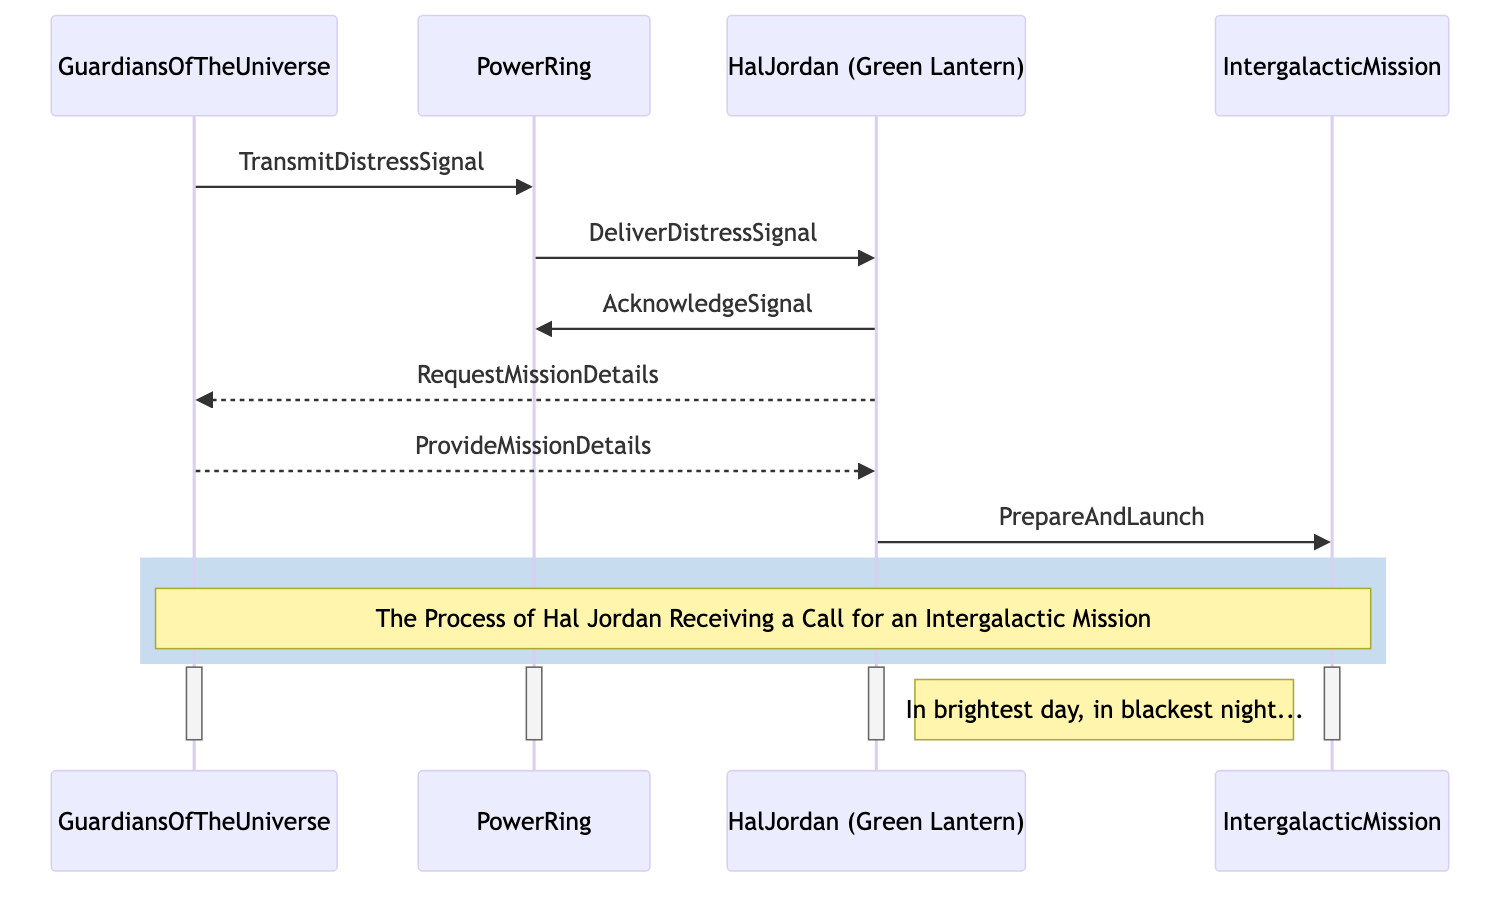What is the first action in the sequence? The first action in the sequence is where the "Guardians of the Universe" transmit the "Distress Signal" to the "Power Ring".
Answer: TransmitDistressSignal How many actors are involved in the process? The diagram includes two actors: "Guardians of the Universe" and "Hal Jordan (Green Lantern)".
Answer: 2 What message does Hal Jordan send after acknowledging the signal? After acknowledging the signal, Hal Jordan requests mission details from the "Guardians of the Universe".
Answer: RequestMissionDetails What object does Hal Jordan prepare and launch? Hal Jordan prepares and launches the "Intergalactic Mission".
Answer: IntergalacticMission Which entity delivers the distress signal to Hal Jordan? The "Power Ring" delivers the distress signal to Hal Jordan.
Answer: PowerRing What is the sequential order of the actions from the Guardians of the Universe to Hal Jordan? The sequence is: "Transmit Distress Signal" to "Deliver Distress Signal" to "Acknowledge Signal" to "Request Mission Details".
Answer: TransmitDistressSignal, DeliverDistressSignal, AcknowledgeSignal, RequestMissionDetails What kind of response does Hal Jordan send after receiving the distress signal? Hal Jordan sends a request for mission details as a response.
Answer: RequestMissionDetails What is the final action performed by Hal Jordan? The final action performed by Hal Jordan is to prepare and launch the mission.
Answer: PrepareAndLaunch 